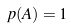<formula> <loc_0><loc_0><loc_500><loc_500>p ( A ) = 1</formula> 